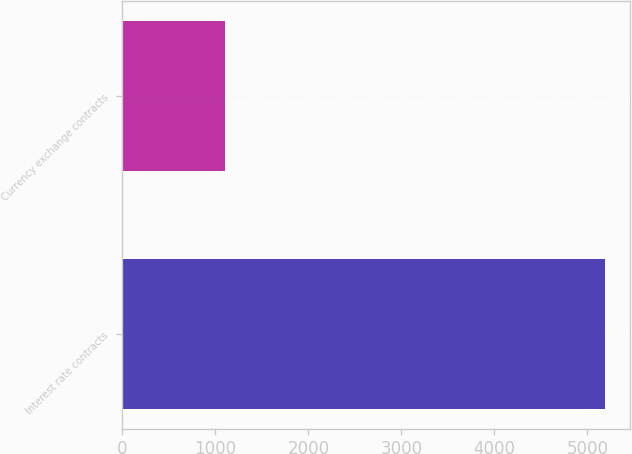<chart> <loc_0><loc_0><loc_500><loc_500><bar_chart><fcel>Interest rate contracts<fcel>Currency exchange contracts<nl><fcel>5194<fcel>1106<nl></chart> 